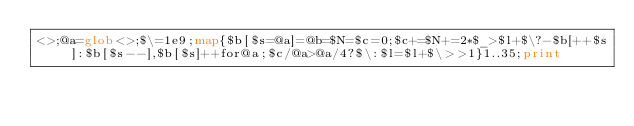<code> <loc_0><loc_0><loc_500><loc_500><_Perl_><>;@a=glob<>;$\=1e9;map{$b[$s=@a]=@b=$N=$c=0;$c+=$N+=2*$_>$l+$\?-$b[++$s]:$b[$s--],$b[$s]++for@a;$c/@a>@a/4?$\:$l=$l+$\>>1}1..35;print</code> 